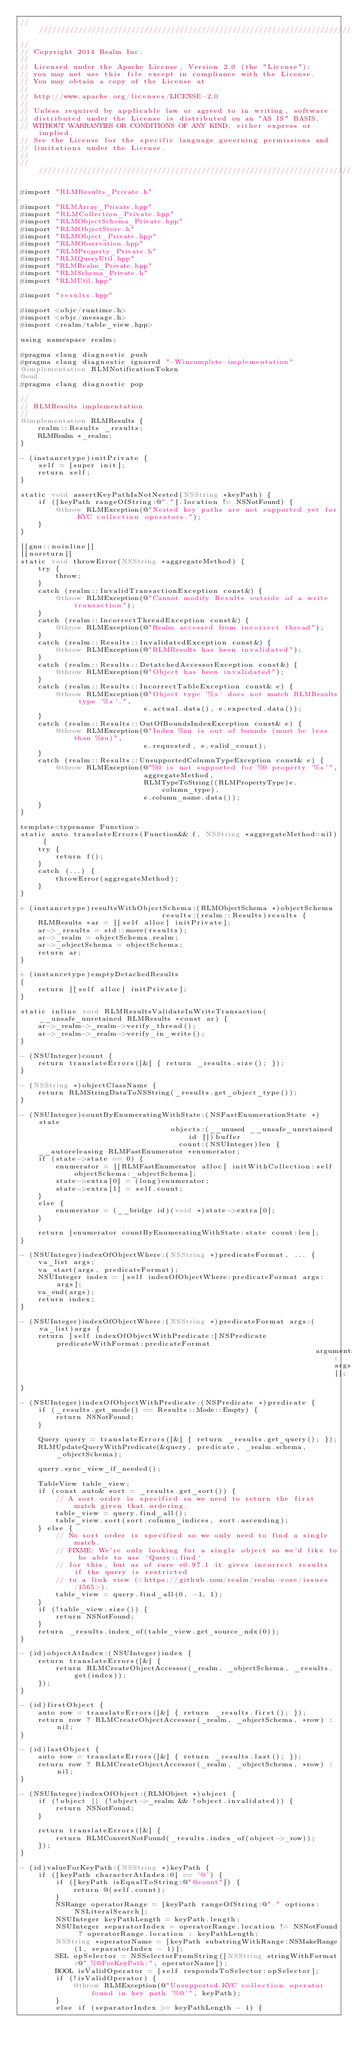Convert code to text. <code><loc_0><loc_0><loc_500><loc_500><_ObjectiveC_>////////////////////////////////////////////////////////////////////////////
//
// Copyright 2014 Realm Inc.
//
// Licensed under the Apache License, Version 2.0 (the "License");
// you may not use this file except in compliance with the License.
// You may obtain a copy of the License at
//
// http://www.apache.org/licenses/LICENSE-2.0
//
// Unless required by applicable law or agreed to in writing, software
// distributed under the License is distributed on an "AS IS" BASIS,
// WITHOUT WARRANTIES OR CONDITIONS OF ANY KIND, either express or implied.
// See the License for the specific language governing permissions and
// limitations under the License.
//
////////////////////////////////////////////////////////////////////////////

#import "RLMResults_Private.h"

#import "RLMArray_Private.hpp"
#import "RLMCollection_Private.hpp"
#import "RLMObjectSchema_Private.hpp"
#import "RLMObjectStore.h"
#import "RLMObject_Private.hpp"
#import "RLMObservation.hpp"
#import "RLMProperty_Private.h"
#import "RLMQueryUtil.hpp"
#import "RLMRealm_Private.hpp"
#import "RLMSchema_Private.h"
#import "RLMUtil.hpp"

#import "results.hpp"

#import <objc/runtime.h>
#import <objc/message.h>
#import <realm/table_view.hpp>

using namespace realm;

#pragma clang diagnostic push
#pragma clang diagnostic ignored "-Wincomplete-implementation"
@implementation RLMNotificationToken
@end
#pragma clang diagnostic pop

//
// RLMResults implementation
//
@implementation RLMResults {
    realm::Results _results;
    RLMRealm *_realm;
}

- (instancetype)initPrivate {
    self = [super init];
    return self;
}

static void assertKeyPathIsNotNested(NSString *keyPath) {
    if ([keyPath rangeOfString:@"."].location != NSNotFound) {
        @throw RLMException(@"Nested key paths are not supported yet for KVC collection operators.");
    }
}

[[gnu::noinline]]
[[noreturn]]
static void throwError(NSString *aggregateMethod) {
    try {
        throw;
    }
    catch (realm::InvalidTransactionException const&) {
        @throw RLMException(@"Cannot modify Results outside of a write transaction");
    }
    catch (realm::IncorrectThreadException const&) {
        @throw RLMException(@"Realm accessed from incorrect thread");
    }
    catch (realm::Results::InvalidatedException const&) {
        @throw RLMException(@"RLMResults has been invalidated");
    }
    catch (realm::Results::DetatchedAccessorException const&) {
        @throw RLMException(@"Object has been invalidated");
    }
    catch (realm::Results::IncorrectTableException const& e) {
        @throw RLMException(@"Object type '%s' does not match RLMResults type '%s'.",
                            e.actual.data(), e.expected.data());
    }
    catch (realm::Results::OutOfBoundsIndexException const& e) {
        @throw RLMException(@"Index %zu is out of bounds (must be less than %zu)",
                            e.requested, e.valid_count);
    }
    catch (realm::Results::UnsupportedColumnTypeException const& e) {
        @throw RLMException(@"%@ is not supported for %@ property '%s'",
                            aggregateMethod,
                            RLMTypeToString((RLMPropertyType)e.column_type),
                            e.column_name.data());
    }
}

template<typename Function>
static auto translateErrors(Function&& f, NSString *aggregateMethod=nil) {
    try {
        return f();
    }
    catch (...) {
        throwError(aggregateMethod);
    }
}

+ (instancetype)resultsWithObjectSchema:(RLMObjectSchema *)objectSchema
                                results:(realm::Results)results {
    RLMResults *ar = [[self alloc] initPrivate];
    ar->_results = std::move(results);
    ar->_realm = objectSchema.realm;
    ar->_objectSchema = objectSchema;
    return ar;
}

+ (instancetype)emptyDetachedResults
{
    return [[self alloc] initPrivate];
}

static inline void RLMResultsValidateInWriteTransaction(__unsafe_unretained RLMResults *const ar) {
    ar->_realm->_realm->verify_thread();
    ar->_realm->_realm->verify_in_write();
}

- (NSUInteger)count {
    return translateErrors([&] { return _results.size(); });
}

- (NSString *)objectClassName {
    return RLMStringDataToNSString(_results.get_object_type());
}

- (NSUInteger)countByEnumeratingWithState:(NSFastEnumerationState *)state
                                  objects:(__unused __unsafe_unretained id [])buffer
                                    count:(NSUInteger)len {
    __autoreleasing RLMFastEnumerator *enumerator;
    if (state->state == 0) {
        enumerator = [[RLMFastEnumerator alloc] initWithCollection:self objectSchema:_objectSchema];
        state->extra[0] = (long)enumerator;
        state->extra[1] = self.count;
    }
    else {
        enumerator = (__bridge id)(void *)state->extra[0];
    }

    return [enumerator countByEnumeratingWithState:state count:len];
}

- (NSUInteger)indexOfObjectWhere:(NSString *)predicateFormat, ... {
    va_list args;
    va_start(args, predicateFormat);
    NSUInteger index = [self indexOfObjectWhere:predicateFormat args:args];
    va_end(args);
    return index;
}

- (NSUInteger)indexOfObjectWhere:(NSString *)predicateFormat args:(va_list)args {
    return [self indexOfObjectWithPredicate:[NSPredicate predicateWithFormat:predicateFormat
                                                                   arguments:args]];
}

- (NSUInteger)indexOfObjectWithPredicate:(NSPredicate *)predicate {
    if (_results.get_mode() == Results::Mode::Empty) {
        return NSNotFound;
    }

    Query query = translateErrors([&] { return _results.get_query(); });
    RLMUpdateQueryWithPredicate(&query, predicate, _realm.schema, _objectSchema);

    query.sync_view_if_needed();

    TableView table_view;
    if (const auto& sort = _results.get_sort()) {
        // A sort order is specified so we need to return the first match given that ordering.
        table_view = query.find_all();
        table_view.sort(sort.column_indices, sort.ascending);
    } else {
        // No sort order is specified so we only need to find a single match.
        // FIXME: We're only looking for a single object so we'd like to be able to use `Query::find`
        // for this, but as of core v0.97.1 it gives incorrect results if the query is restricted
        // to a link view (<https://github.com/realm/realm-core/issues/1565>).
        table_view = query.find_all(0, -1, 1);
    }
    if (!table_view.size()) {
        return NSNotFound;
    }
    return _results.index_of(table_view.get_source_ndx(0));
}

- (id)objectAtIndex:(NSUInteger)index {
    return translateErrors([&] {
        return RLMCreateObjectAccessor(_realm, _objectSchema, _results.get(index));
    });
}

- (id)firstObject {
    auto row = translateErrors([&] { return _results.first(); });
    return row ? RLMCreateObjectAccessor(_realm, _objectSchema, *row) : nil;
}

- (id)lastObject {
    auto row = translateErrors([&] { return _results.last(); });
    return row ? RLMCreateObjectAccessor(_realm, _objectSchema, *row) : nil;
}

- (NSUInteger)indexOfObject:(RLMObject *)object {
    if (!object || (!object->_realm && !object.invalidated)) {
        return NSNotFound;
    }

    return translateErrors([&] {
        return RLMConvertNotFound(_results.index_of(object->_row));
    });
}

- (id)valueForKeyPath:(NSString *)keyPath {
    if ([keyPath characterAtIndex:0] == '@') {
        if ([keyPath isEqualToString:@"@count"]) {
            return @(self.count);
        }
        NSRange operatorRange = [keyPath rangeOfString:@"." options:NSLiteralSearch];
        NSUInteger keyPathLength = keyPath.length;
        NSUInteger separatorIndex = operatorRange.location != NSNotFound ? operatorRange.location : keyPathLength;
        NSString *operatorName = [keyPath substringWithRange:NSMakeRange(1, separatorIndex - 1)];
        SEL opSelector = NSSelectorFromString([NSString stringWithFormat:@"_%@ForKeyPath:", operatorName]);
        BOOL isValidOperator = [self respondsToSelector:opSelector];
        if (!isValidOperator) {
            @throw RLMException(@"Unsupported KVC collection operator found in key path '%@'", keyPath);
        }
        else if (separatorIndex >= keyPathLength - 1) {</code> 